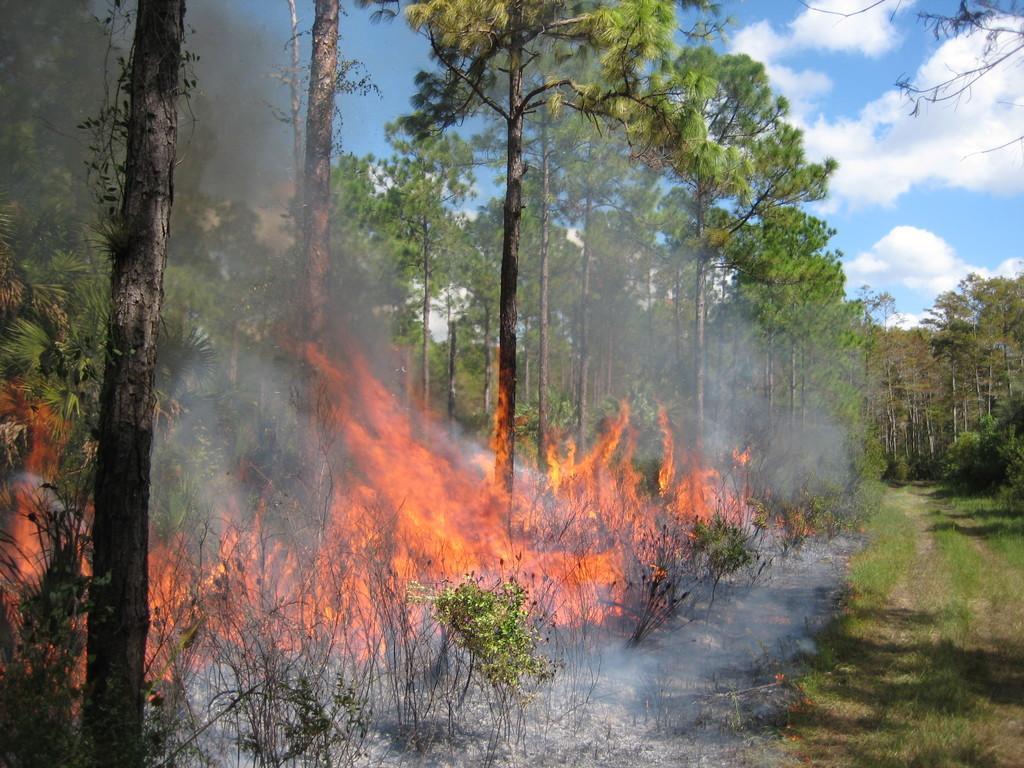Describe this image in one or two sentences. As we can see in the image there is grass, plants, fire and trees. On the top there is sky and clouds. 